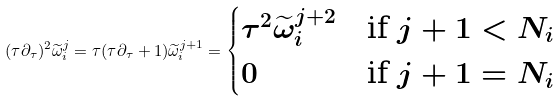<formula> <loc_0><loc_0><loc_500><loc_500>( \tau \partial _ { \tau } ) ^ { 2 } \widetilde { \omega } _ { i } ^ { j } = \tau ( \tau \partial _ { \tau } + 1 ) \widetilde { \omega } _ { i } ^ { j + 1 } = \begin{cases} \tau ^ { 2 } \widetilde { \omega } _ { i } ^ { j + 2 } & \text {if $j+1<N_{i}$} \\ 0 & \text {if $j+1=N_{i}$} \end{cases}</formula> 